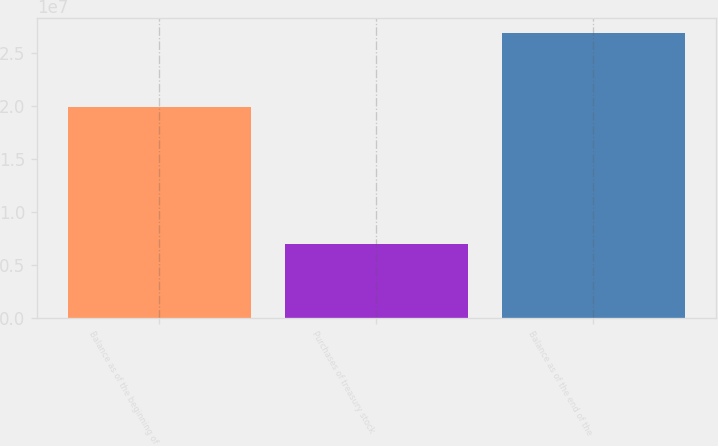Convert chart. <chart><loc_0><loc_0><loc_500><loc_500><bar_chart><fcel>Balance as of the beginning of<fcel>Purchases of treasury stock<fcel>Balance as of the end of the<nl><fcel>1.99165e+07<fcel>7.03442e+06<fcel>2.69509e+07<nl></chart> 